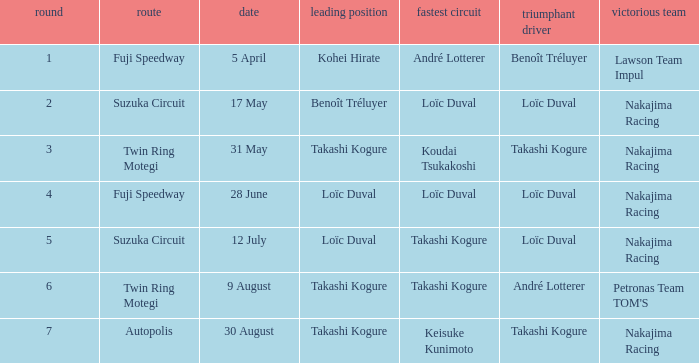Could you parse the entire table as a dict? {'header': ['round', 'route', 'date', 'leading position', 'fastest circuit', 'triumphant driver', 'victorious team'], 'rows': [['1', 'Fuji Speedway', '5 April', 'Kohei Hirate', 'André Lotterer', 'Benoît Tréluyer', 'Lawson Team Impul'], ['2', 'Suzuka Circuit', '17 May', 'Benoît Tréluyer', 'Loïc Duval', 'Loïc Duval', 'Nakajima Racing'], ['3', 'Twin Ring Motegi', '31 May', 'Takashi Kogure', 'Koudai Tsukakoshi', 'Takashi Kogure', 'Nakajima Racing'], ['4', 'Fuji Speedway', '28 June', 'Loïc Duval', 'Loïc Duval', 'Loïc Duval', 'Nakajima Racing'], ['5', 'Suzuka Circuit', '12 July', 'Loïc Duval', 'Takashi Kogure', 'Loïc Duval', 'Nakajima Racing'], ['6', 'Twin Ring Motegi', '9 August', 'Takashi Kogure', 'Takashi Kogure', 'André Lotterer', "Petronas Team TOM'S"], ['7', 'Autopolis', '30 August', 'Takashi Kogure', 'Keisuke Kunimoto', 'Takashi Kogure', 'Nakajima Racing']]} Who was the driver for the winning team Lawson Team Impul? Benoît Tréluyer. 